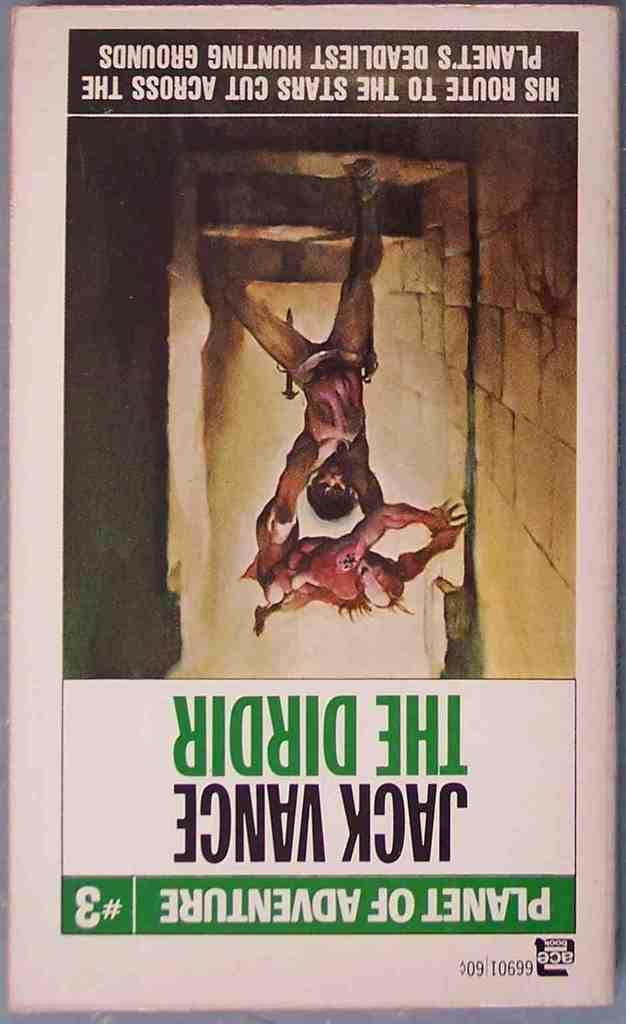<image>
Render a clear and concise summary of the photo. A Planet of Adventures paperback book is written by Jack Vance. 